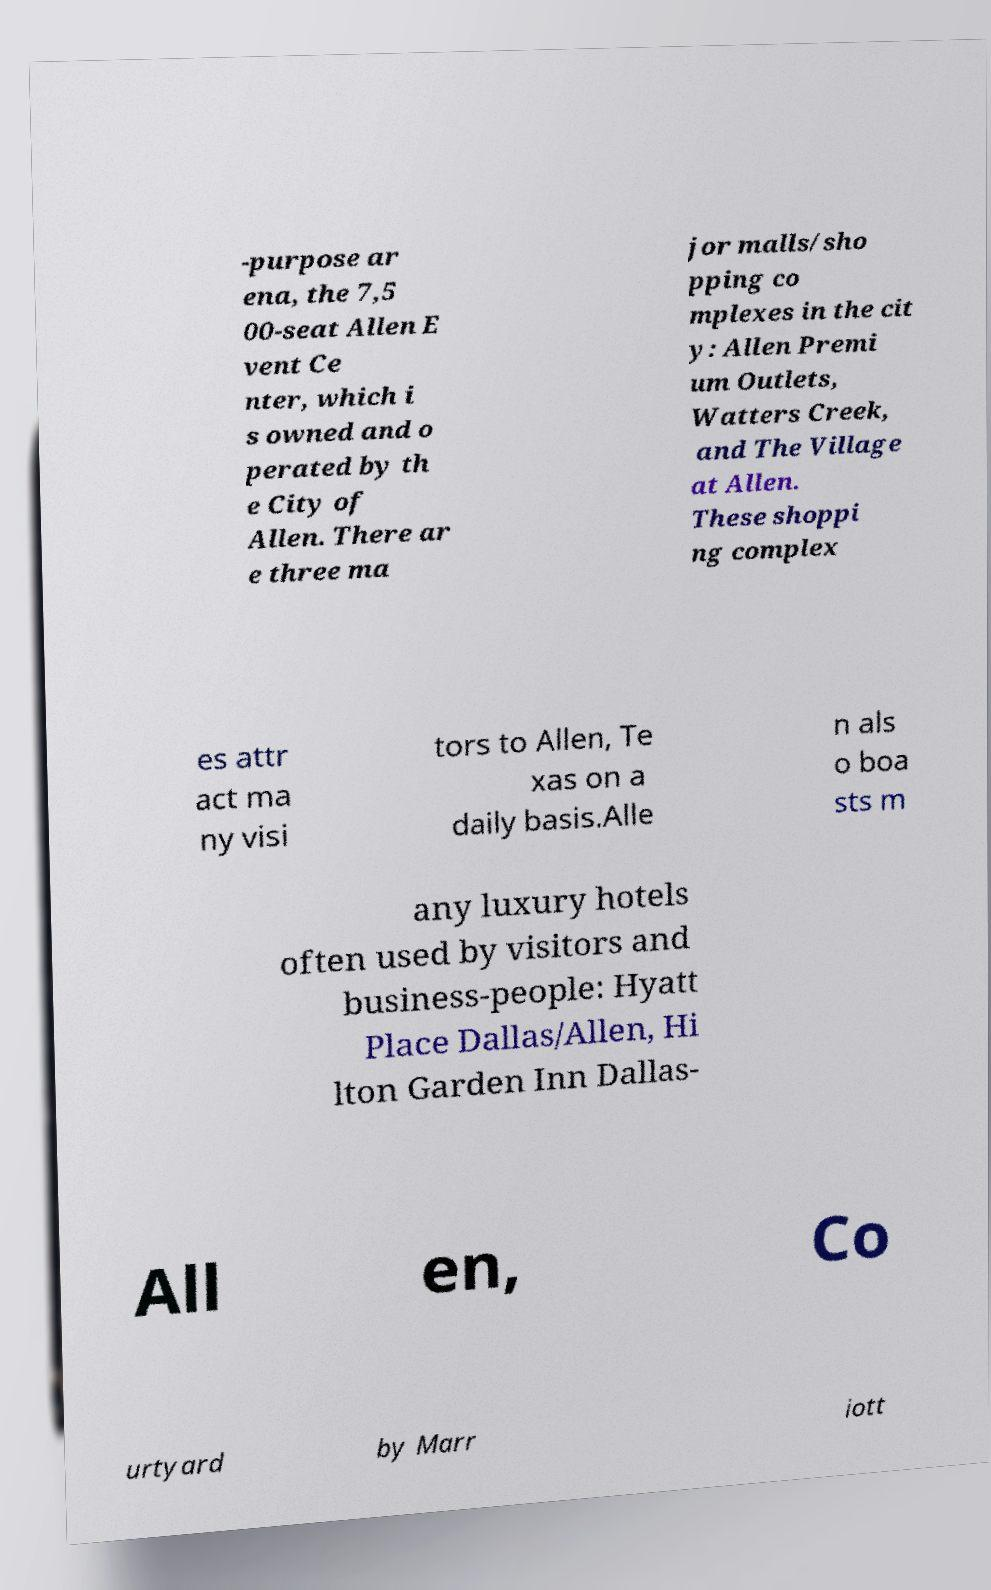Can you accurately transcribe the text from the provided image for me? -purpose ar ena, the 7,5 00-seat Allen E vent Ce nter, which i s owned and o perated by th e City of Allen. There ar e three ma jor malls/sho pping co mplexes in the cit y: Allen Premi um Outlets, Watters Creek, and The Village at Allen. These shoppi ng complex es attr act ma ny visi tors to Allen, Te xas on a daily basis.Alle n als o boa sts m any luxury hotels often used by visitors and business-people: Hyatt Place Dallas/Allen, Hi lton Garden Inn Dallas- All en, Co urtyard by Marr iott 